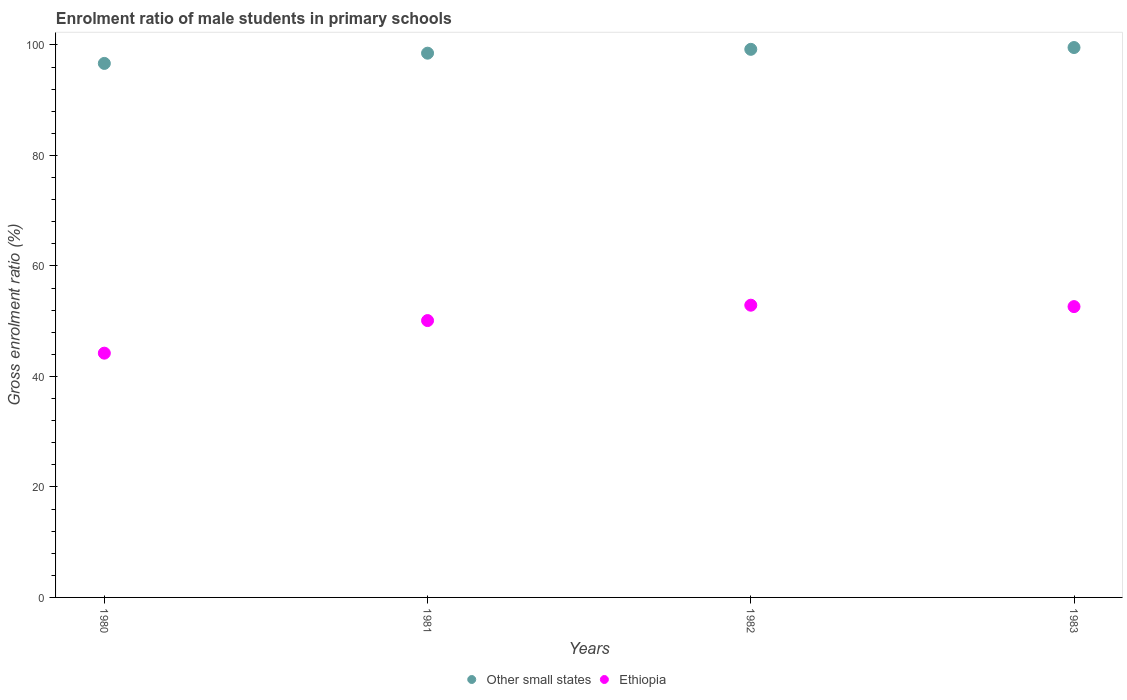Is the number of dotlines equal to the number of legend labels?
Give a very brief answer. Yes. What is the enrolment ratio of male students in primary schools in Other small states in 1981?
Keep it short and to the point. 98.51. Across all years, what is the maximum enrolment ratio of male students in primary schools in Ethiopia?
Your answer should be compact. 52.89. Across all years, what is the minimum enrolment ratio of male students in primary schools in Ethiopia?
Provide a succinct answer. 44.21. In which year was the enrolment ratio of male students in primary schools in Ethiopia maximum?
Give a very brief answer. 1982. What is the total enrolment ratio of male students in primary schools in Ethiopia in the graph?
Give a very brief answer. 199.86. What is the difference between the enrolment ratio of male students in primary schools in Ethiopia in 1980 and that in 1981?
Make the answer very short. -5.9. What is the difference between the enrolment ratio of male students in primary schools in Ethiopia in 1983 and the enrolment ratio of male students in primary schools in Other small states in 1980?
Give a very brief answer. -44.02. What is the average enrolment ratio of male students in primary schools in Other small states per year?
Offer a terse response. 98.48. In the year 1980, what is the difference between the enrolment ratio of male students in primary schools in Other small states and enrolment ratio of male students in primary schools in Ethiopia?
Keep it short and to the point. 52.44. In how many years, is the enrolment ratio of male students in primary schools in Ethiopia greater than 56 %?
Ensure brevity in your answer.  0. What is the ratio of the enrolment ratio of male students in primary schools in Other small states in 1980 to that in 1983?
Offer a terse response. 0.97. Is the difference between the enrolment ratio of male students in primary schools in Other small states in 1981 and 1983 greater than the difference between the enrolment ratio of male students in primary schools in Ethiopia in 1981 and 1983?
Provide a succinct answer. Yes. What is the difference between the highest and the second highest enrolment ratio of male students in primary schools in Other small states?
Your answer should be compact. 0.33. What is the difference between the highest and the lowest enrolment ratio of male students in primary schools in Ethiopia?
Offer a very short reply. 8.68. Does the enrolment ratio of male students in primary schools in Other small states monotonically increase over the years?
Provide a succinct answer. Yes. Is the enrolment ratio of male students in primary schools in Other small states strictly greater than the enrolment ratio of male students in primary schools in Ethiopia over the years?
Give a very brief answer. Yes. Is the enrolment ratio of male students in primary schools in Ethiopia strictly less than the enrolment ratio of male students in primary schools in Other small states over the years?
Ensure brevity in your answer.  Yes. How many years are there in the graph?
Your response must be concise. 4. Does the graph contain any zero values?
Ensure brevity in your answer.  No. Does the graph contain grids?
Your answer should be compact. No. How many legend labels are there?
Ensure brevity in your answer.  2. How are the legend labels stacked?
Your response must be concise. Horizontal. What is the title of the graph?
Provide a short and direct response. Enrolment ratio of male students in primary schools. Does "Chad" appear as one of the legend labels in the graph?
Your answer should be compact. No. What is the label or title of the Y-axis?
Your answer should be very brief. Gross enrolment ratio (%). What is the Gross enrolment ratio (%) of Other small states in 1980?
Keep it short and to the point. 96.66. What is the Gross enrolment ratio (%) of Ethiopia in 1980?
Provide a short and direct response. 44.21. What is the Gross enrolment ratio (%) of Other small states in 1981?
Provide a succinct answer. 98.51. What is the Gross enrolment ratio (%) in Ethiopia in 1981?
Ensure brevity in your answer.  50.11. What is the Gross enrolment ratio (%) of Other small states in 1982?
Keep it short and to the point. 99.21. What is the Gross enrolment ratio (%) of Ethiopia in 1982?
Make the answer very short. 52.89. What is the Gross enrolment ratio (%) of Other small states in 1983?
Ensure brevity in your answer.  99.53. What is the Gross enrolment ratio (%) in Ethiopia in 1983?
Keep it short and to the point. 52.64. Across all years, what is the maximum Gross enrolment ratio (%) in Other small states?
Offer a terse response. 99.53. Across all years, what is the maximum Gross enrolment ratio (%) in Ethiopia?
Ensure brevity in your answer.  52.89. Across all years, what is the minimum Gross enrolment ratio (%) in Other small states?
Give a very brief answer. 96.66. Across all years, what is the minimum Gross enrolment ratio (%) of Ethiopia?
Ensure brevity in your answer.  44.21. What is the total Gross enrolment ratio (%) in Other small states in the graph?
Offer a very short reply. 393.91. What is the total Gross enrolment ratio (%) in Ethiopia in the graph?
Your response must be concise. 199.86. What is the difference between the Gross enrolment ratio (%) of Other small states in 1980 and that in 1981?
Ensure brevity in your answer.  -1.85. What is the difference between the Gross enrolment ratio (%) of Ethiopia in 1980 and that in 1981?
Your answer should be very brief. -5.9. What is the difference between the Gross enrolment ratio (%) in Other small states in 1980 and that in 1982?
Your response must be concise. -2.55. What is the difference between the Gross enrolment ratio (%) of Ethiopia in 1980 and that in 1982?
Your answer should be very brief. -8.68. What is the difference between the Gross enrolment ratio (%) in Other small states in 1980 and that in 1983?
Your answer should be very brief. -2.87. What is the difference between the Gross enrolment ratio (%) in Ethiopia in 1980 and that in 1983?
Offer a very short reply. -8.43. What is the difference between the Gross enrolment ratio (%) in Other small states in 1981 and that in 1982?
Provide a succinct answer. -0.7. What is the difference between the Gross enrolment ratio (%) of Ethiopia in 1981 and that in 1982?
Offer a very short reply. -2.78. What is the difference between the Gross enrolment ratio (%) of Other small states in 1981 and that in 1983?
Provide a succinct answer. -1.02. What is the difference between the Gross enrolment ratio (%) in Ethiopia in 1981 and that in 1983?
Offer a very short reply. -2.53. What is the difference between the Gross enrolment ratio (%) in Other small states in 1982 and that in 1983?
Your response must be concise. -0.33. What is the difference between the Gross enrolment ratio (%) in Ethiopia in 1982 and that in 1983?
Offer a terse response. 0.26. What is the difference between the Gross enrolment ratio (%) of Other small states in 1980 and the Gross enrolment ratio (%) of Ethiopia in 1981?
Make the answer very short. 46.55. What is the difference between the Gross enrolment ratio (%) in Other small states in 1980 and the Gross enrolment ratio (%) in Ethiopia in 1982?
Give a very brief answer. 43.76. What is the difference between the Gross enrolment ratio (%) in Other small states in 1980 and the Gross enrolment ratio (%) in Ethiopia in 1983?
Make the answer very short. 44.02. What is the difference between the Gross enrolment ratio (%) of Other small states in 1981 and the Gross enrolment ratio (%) of Ethiopia in 1982?
Provide a succinct answer. 45.62. What is the difference between the Gross enrolment ratio (%) in Other small states in 1981 and the Gross enrolment ratio (%) in Ethiopia in 1983?
Give a very brief answer. 45.87. What is the difference between the Gross enrolment ratio (%) in Other small states in 1982 and the Gross enrolment ratio (%) in Ethiopia in 1983?
Provide a succinct answer. 46.57. What is the average Gross enrolment ratio (%) in Other small states per year?
Your answer should be very brief. 98.48. What is the average Gross enrolment ratio (%) of Ethiopia per year?
Ensure brevity in your answer.  49.96. In the year 1980, what is the difference between the Gross enrolment ratio (%) of Other small states and Gross enrolment ratio (%) of Ethiopia?
Provide a succinct answer. 52.44. In the year 1981, what is the difference between the Gross enrolment ratio (%) in Other small states and Gross enrolment ratio (%) in Ethiopia?
Offer a very short reply. 48.4. In the year 1982, what is the difference between the Gross enrolment ratio (%) of Other small states and Gross enrolment ratio (%) of Ethiopia?
Provide a short and direct response. 46.31. In the year 1983, what is the difference between the Gross enrolment ratio (%) of Other small states and Gross enrolment ratio (%) of Ethiopia?
Give a very brief answer. 46.89. What is the ratio of the Gross enrolment ratio (%) in Other small states in 1980 to that in 1981?
Offer a very short reply. 0.98. What is the ratio of the Gross enrolment ratio (%) in Ethiopia in 1980 to that in 1981?
Give a very brief answer. 0.88. What is the ratio of the Gross enrolment ratio (%) in Other small states in 1980 to that in 1982?
Keep it short and to the point. 0.97. What is the ratio of the Gross enrolment ratio (%) of Ethiopia in 1980 to that in 1982?
Ensure brevity in your answer.  0.84. What is the ratio of the Gross enrolment ratio (%) of Other small states in 1980 to that in 1983?
Ensure brevity in your answer.  0.97. What is the ratio of the Gross enrolment ratio (%) in Ethiopia in 1980 to that in 1983?
Provide a short and direct response. 0.84. What is the ratio of the Gross enrolment ratio (%) in Other small states in 1981 to that in 1982?
Provide a succinct answer. 0.99. What is the ratio of the Gross enrolment ratio (%) of Ethiopia in 1982 to that in 1983?
Make the answer very short. 1. What is the difference between the highest and the second highest Gross enrolment ratio (%) of Other small states?
Your response must be concise. 0.33. What is the difference between the highest and the second highest Gross enrolment ratio (%) in Ethiopia?
Give a very brief answer. 0.26. What is the difference between the highest and the lowest Gross enrolment ratio (%) in Other small states?
Offer a very short reply. 2.87. What is the difference between the highest and the lowest Gross enrolment ratio (%) of Ethiopia?
Your response must be concise. 8.68. 